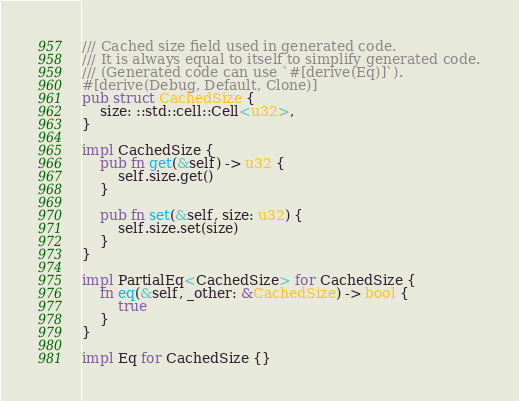Convert code to text. <code><loc_0><loc_0><loc_500><loc_500><_Rust_>/// Cached size field used in generated code.
/// It is always equal to itself to simplify generated code.
/// (Generated code can use `#[derive(Eq)]`).
#[derive(Debug, Default, Clone)]
pub struct CachedSize {
    size: ::std::cell::Cell<u32>,
}

impl CachedSize {
    pub fn get(&self) -> u32 {
        self.size.get()
    }

    pub fn set(&self, size: u32) {
        self.size.set(size)
    }
}

impl PartialEq<CachedSize> for CachedSize {
    fn eq(&self, _other: &CachedSize) -> bool {
        true
    }
}

impl Eq for CachedSize {}
</code> 